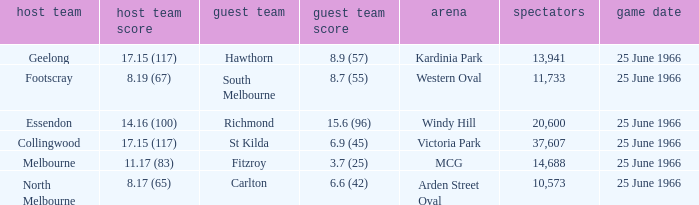Where did the away team score 8.7 (55)? Western Oval. 